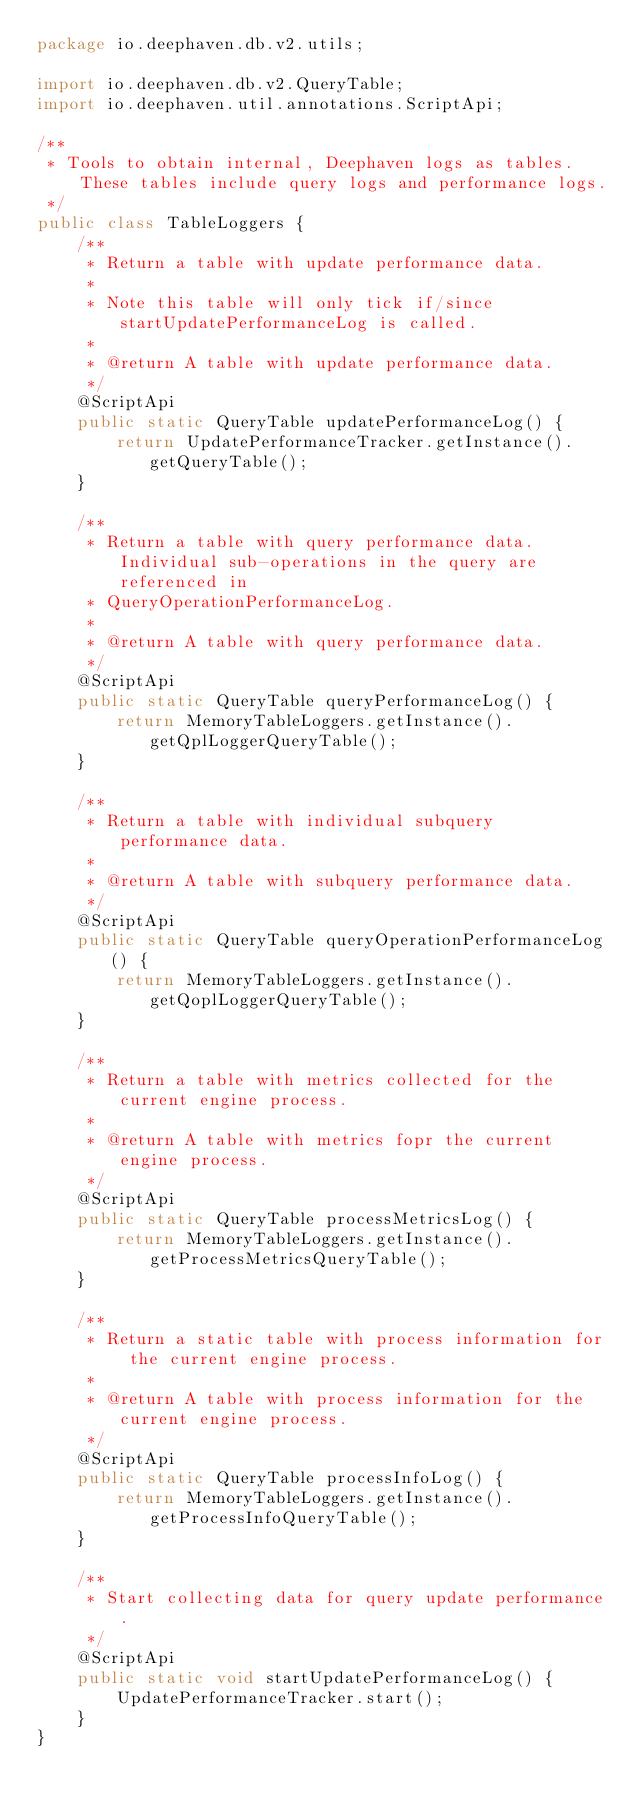<code> <loc_0><loc_0><loc_500><loc_500><_Java_>package io.deephaven.db.v2.utils;

import io.deephaven.db.v2.QueryTable;
import io.deephaven.util.annotations.ScriptApi;

/**
 * Tools to obtain internal, Deephaven logs as tables. These tables include query logs and performance logs.
 */
public class TableLoggers {
    /**
     * Return a table with update performance data.
     *
     * Note this table will only tick if/since startUpdatePerformanceLog is called.
     *
     * @return A table with update performance data.
     */
    @ScriptApi
    public static QueryTable updatePerformanceLog() {
        return UpdatePerformanceTracker.getInstance().getQueryTable();
    }

    /**
     * Return a table with query performance data. Individual sub-operations in the query are referenced in
     * QueryOperationPerformanceLog.
     *
     * @return A table with query performance data.
     */
    @ScriptApi
    public static QueryTable queryPerformanceLog() {
        return MemoryTableLoggers.getInstance().getQplLoggerQueryTable();
    }

    /**
     * Return a table with individual subquery performance data.
     *
     * @return A table with subquery performance data.
     */
    @ScriptApi
    public static QueryTable queryOperationPerformanceLog() {
        return MemoryTableLoggers.getInstance().getQoplLoggerQueryTable();
    }

    /**
     * Return a table with metrics collected for the current engine process.
     *
     * @return A table with metrics fopr the current engine process.
     */
    @ScriptApi
    public static QueryTable processMetricsLog() {
        return MemoryTableLoggers.getInstance().getProcessMetricsQueryTable();
    }

    /**
     * Return a static table with process information for the current engine process.
     *
     * @return A table with process information for the current engine process.
     */
    @ScriptApi
    public static QueryTable processInfoLog() {
        return MemoryTableLoggers.getInstance().getProcessInfoQueryTable();
    }

    /**
     * Start collecting data for query update performance.
     */
    @ScriptApi
    public static void startUpdatePerformanceLog() {
        UpdatePerformanceTracker.start();
    }
}
</code> 